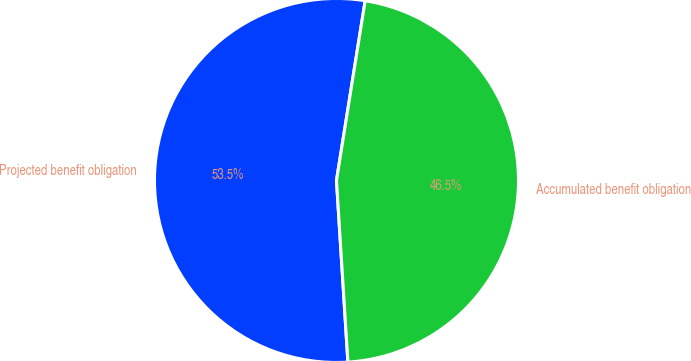<chart> <loc_0><loc_0><loc_500><loc_500><pie_chart><fcel>Projected benefit obligation<fcel>Accumulated benefit obligation<nl><fcel>53.52%<fcel>46.48%<nl></chart> 